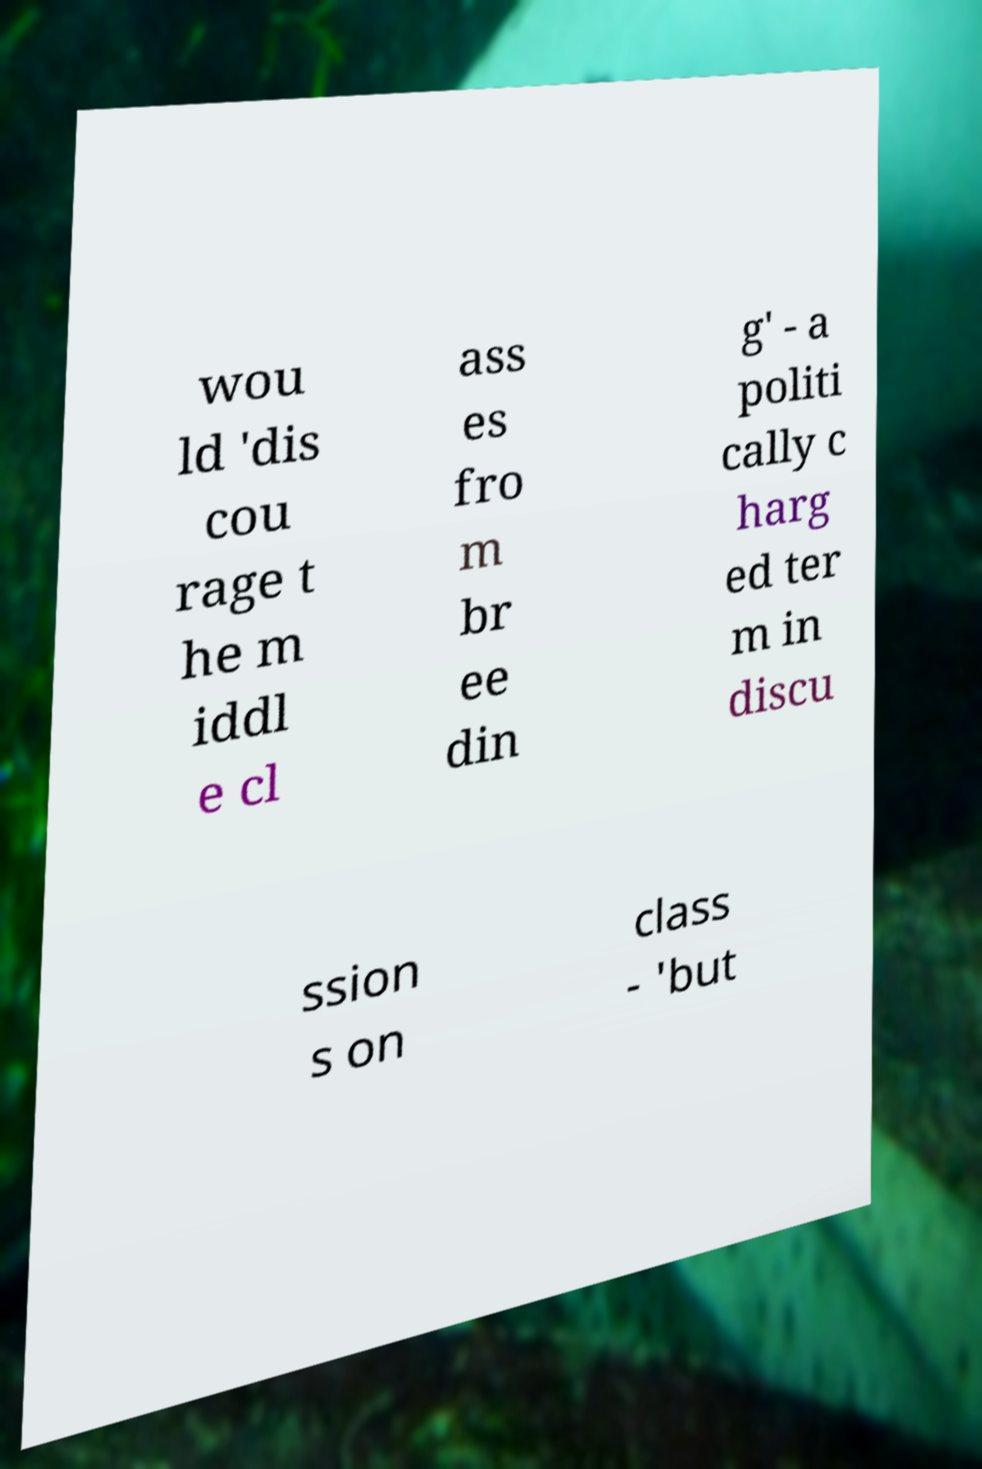Could you assist in decoding the text presented in this image and type it out clearly? wou ld 'dis cou rage t he m iddl e cl ass es fro m br ee din g' - a politi cally c harg ed ter m in discu ssion s on class - 'but 